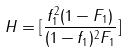<formula> <loc_0><loc_0><loc_500><loc_500>H = [ \frac { f _ { 1 } ^ { 2 } ( 1 - F _ { 1 } ) } { ( 1 - f _ { 1 } ) ^ { 2 } F _ { 1 } } ]</formula> 